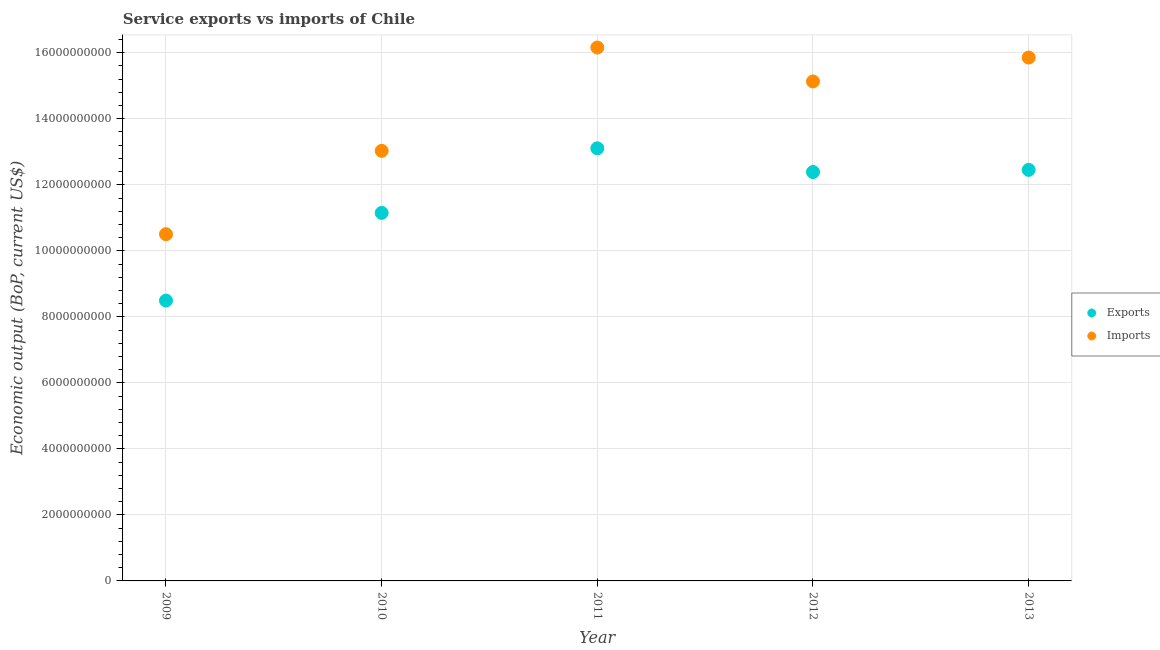Is the number of dotlines equal to the number of legend labels?
Offer a very short reply. Yes. What is the amount of service exports in 2013?
Provide a succinct answer. 1.25e+1. Across all years, what is the maximum amount of service imports?
Keep it short and to the point. 1.62e+1. Across all years, what is the minimum amount of service imports?
Give a very brief answer. 1.05e+1. In which year was the amount of service exports maximum?
Ensure brevity in your answer.  2011. In which year was the amount of service imports minimum?
Ensure brevity in your answer.  2009. What is the total amount of service imports in the graph?
Ensure brevity in your answer.  7.07e+1. What is the difference between the amount of service imports in 2010 and that in 2013?
Provide a succinct answer. -2.83e+09. What is the difference between the amount of service exports in 2011 and the amount of service imports in 2010?
Give a very brief answer. 7.67e+07. What is the average amount of service exports per year?
Offer a terse response. 1.15e+1. In the year 2013, what is the difference between the amount of service imports and amount of service exports?
Your answer should be very brief. 3.40e+09. In how many years, is the amount of service exports greater than 8800000000 US$?
Offer a terse response. 4. What is the ratio of the amount of service exports in 2011 to that in 2013?
Give a very brief answer. 1.05. Is the amount of service exports in 2010 less than that in 2012?
Provide a succinct answer. Yes. Is the difference between the amount of service exports in 2009 and 2011 greater than the difference between the amount of service imports in 2009 and 2011?
Your response must be concise. Yes. What is the difference between the highest and the second highest amount of service exports?
Provide a succinct answer. 6.53e+08. What is the difference between the highest and the lowest amount of service exports?
Your answer should be very brief. 4.61e+09. In how many years, is the amount of service exports greater than the average amount of service exports taken over all years?
Keep it short and to the point. 3. Is the sum of the amount of service exports in 2010 and 2011 greater than the maximum amount of service imports across all years?
Give a very brief answer. Yes. How many dotlines are there?
Provide a succinct answer. 2. How many years are there in the graph?
Your answer should be very brief. 5. How are the legend labels stacked?
Offer a terse response. Vertical. What is the title of the graph?
Your answer should be very brief. Service exports vs imports of Chile. Does "From World Bank" appear as one of the legend labels in the graph?
Make the answer very short. No. What is the label or title of the Y-axis?
Make the answer very short. Economic output (BoP, current US$). What is the Economic output (BoP, current US$) in Exports in 2009?
Your answer should be compact. 8.49e+09. What is the Economic output (BoP, current US$) in Imports in 2009?
Provide a succinct answer. 1.05e+1. What is the Economic output (BoP, current US$) in Exports in 2010?
Give a very brief answer. 1.11e+1. What is the Economic output (BoP, current US$) of Imports in 2010?
Your answer should be very brief. 1.30e+1. What is the Economic output (BoP, current US$) of Exports in 2011?
Your response must be concise. 1.31e+1. What is the Economic output (BoP, current US$) of Imports in 2011?
Ensure brevity in your answer.  1.62e+1. What is the Economic output (BoP, current US$) in Exports in 2012?
Your answer should be compact. 1.24e+1. What is the Economic output (BoP, current US$) of Imports in 2012?
Provide a short and direct response. 1.51e+1. What is the Economic output (BoP, current US$) of Exports in 2013?
Make the answer very short. 1.25e+1. What is the Economic output (BoP, current US$) of Imports in 2013?
Your response must be concise. 1.59e+1. Across all years, what is the maximum Economic output (BoP, current US$) of Exports?
Provide a short and direct response. 1.31e+1. Across all years, what is the maximum Economic output (BoP, current US$) of Imports?
Your answer should be compact. 1.62e+1. Across all years, what is the minimum Economic output (BoP, current US$) in Exports?
Your answer should be very brief. 8.49e+09. Across all years, what is the minimum Economic output (BoP, current US$) of Imports?
Provide a short and direct response. 1.05e+1. What is the total Economic output (BoP, current US$) in Exports in the graph?
Offer a terse response. 5.76e+1. What is the total Economic output (BoP, current US$) of Imports in the graph?
Offer a terse response. 7.07e+1. What is the difference between the Economic output (BoP, current US$) in Exports in 2009 and that in 2010?
Offer a very short reply. -2.66e+09. What is the difference between the Economic output (BoP, current US$) in Imports in 2009 and that in 2010?
Your response must be concise. -2.53e+09. What is the difference between the Economic output (BoP, current US$) of Exports in 2009 and that in 2011?
Your response must be concise. -4.61e+09. What is the difference between the Economic output (BoP, current US$) in Imports in 2009 and that in 2011?
Provide a succinct answer. -5.66e+09. What is the difference between the Economic output (BoP, current US$) of Exports in 2009 and that in 2012?
Keep it short and to the point. -3.89e+09. What is the difference between the Economic output (BoP, current US$) in Imports in 2009 and that in 2012?
Your response must be concise. -4.63e+09. What is the difference between the Economic output (BoP, current US$) of Exports in 2009 and that in 2013?
Ensure brevity in your answer.  -3.96e+09. What is the difference between the Economic output (BoP, current US$) of Imports in 2009 and that in 2013?
Your answer should be compact. -5.35e+09. What is the difference between the Economic output (BoP, current US$) of Exports in 2010 and that in 2011?
Your answer should be very brief. -1.96e+09. What is the difference between the Economic output (BoP, current US$) of Imports in 2010 and that in 2011?
Ensure brevity in your answer.  -3.13e+09. What is the difference between the Economic output (BoP, current US$) of Exports in 2010 and that in 2012?
Provide a short and direct response. -1.24e+09. What is the difference between the Economic output (BoP, current US$) in Imports in 2010 and that in 2012?
Your answer should be compact. -2.10e+09. What is the difference between the Economic output (BoP, current US$) in Exports in 2010 and that in 2013?
Make the answer very short. -1.30e+09. What is the difference between the Economic output (BoP, current US$) of Imports in 2010 and that in 2013?
Offer a terse response. -2.83e+09. What is the difference between the Economic output (BoP, current US$) of Exports in 2011 and that in 2012?
Offer a very short reply. 7.18e+08. What is the difference between the Economic output (BoP, current US$) in Imports in 2011 and that in 2012?
Your answer should be very brief. 1.03e+09. What is the difference between the Economic output (BoP, current US$) in Exports in 2011 and that in 2013?
Keep it short and to the point. 6.53e+08. What is the difference between the Economic output (BoP, current US$) of Imports in 2011 and that in 2013?
Offer a very short reply. 3.04e+08. What is the difference between the Economic output (BoP, current US$) of Exports in 2012 and that in 2013?
Make the answer very short. -6.53e+07. What is the difference between the Economic output (BoP, current US$) of Imports in 2012 and that in 2013?
Give a very brief answer. -7.24e+08. What is the difference between the Economic output (BoP, current US$) of Exports in 2009 and the Economic output (BoP, current US$) of Imports in 2010?
Give a very brief answer. -4.54e+09. What is the difference between the Economic output (BoP, current US$) of Exports in 2009 and the Economic output (BoP, current US$) of Imports in 2011?
Your answer should be very brief. -7.67e+09. What is the difference between the Economic output (BoP, current US$) in Exports in 2009 and the Economic output (BoP, current US$) in Imports in 2012?
Offer a very short reply. -6.64e+09. What is the difference between the Economic output (BoP, current US$) of Exports in 2009 and the Economic output (BoP, current US$) of Imports in 2013?
Give a very brief answer. -7.36e+09. What is the difference between the Economic output (BoP, current US$) in Exports in 2010 and the Economic output (BoP, current US$) in Imports in 2011?
Make the answer very short. -5.01e+09. What is the difference between the Economic output (BoP, current US$) in Exports in 2010 and the Economic output (BoP, current US$) in Imports in 2012?
Ensure brevity in your answer.  -3.98e+09. What is the difference between the Economic output (BoP, current US$) of Exports in 2010 and the Economic output (BoP, current US$) of Imports in 2013?
Ensure brevity in your answer.  -4.71e+09. What is the difference between the Economic output (BoP, current US$) of Exports in 2011 and the Economic output (BoP, current US$) of Imports in 2012?
Ensure brevity in your answer.  -2.03e+09. What is the difference between the Economic output (BoP, current US$) in Exports in 2011 and the Economic output (BoP, current US$) in Imports in 2013?
Offer a very short reply. -2.75e+09. What is the difference between the Economic output (BoP, current US$) in Exports in 2012 and the Economic output (BoP, current US$) in Imports in 2013?
Keep it short and to the point. -3.47e+09. What is the average Economic output (BoP, current US$) of Exports per year?
Provide a succinct answer. 1.15e+1. What is the average Economic output (BoP, current US$) of Imports per year?
Keep it short and to the point. 1.41e+1. In the year 2009, what is the difference between the Economic output (BoP, current US$) of Exports and Economic output (BoP, current US$) of Imports?
Provide a succinct answer. -2.01e+09. In the year 2010, what is the difference between the Economic output (BoP, current US$) in Exports and Economic output (BoP, current US$) in Imports?
Give a very brief answer. -1.88e+09. In the year 2011, what is the difference between the Economic output (BoP, current US$) in Exports and Economic output (BoP, current US$) in Imports?
Give a very brief answer. -3.05e+09. In the year 2012, what is the difference between the Economic output (BoP, current US$) in Exports and Economic output (BoP, current US$) in Imports?
Your response must be concise. -2.74e+09. In the year 2013, what is the difference between the Economic output (BoP, current US$) in Exports and Economic output (BoP, current US$) in Imports?
Provide a succinct answer. -3.40e+09. What is the ratio of the Economic output (BoP, current US$) of Exports in 2009 to that in 2010?
Offer a terse response. 0.76. What is the ratio of the Economic output (BoP, current US$) of Imports in 2009 to that in 2010?
Your answer should be very brief. 0.81. What is the ratio of the Economic output (BoP, current US$) in Exports in 2009 to that in 2011?
Provide a succinct answer. 0.65. What is the ratio of the Economic output (BoP, current US$) in Imports in 2009 to that in 2011?
Give a very brief answer. 0.65. What is the ratio of the Economic output (BoP, current US$) in Exports in 2009 to that in 2012?
Offer a very short reply. 0.69. What is the ratio of the Economic output (BoP, current US$) in Imports in 2009 to that in 2012?
Provide a succinct answer. 0.69. What is the ratio of the Economic output (BoP, current US$) in Exports in 2009 to that in 2013?
Offer a very short reply. 0.68. What is the ratio of the Economic output (BoP, current US$) of Imports in 2009 to that in 2013?
Provide a short and direct response. 0.66. What is the ratio of the Economic output (BoP, current US$) in Exports in 2010 to that in 2011?
Provide a succinct answer. 0.85. What is the ratio of the Economic output (BoP, current US$) in Imports in 2010 to that in 2011?
Offer a very short reply. 0.81. What is the ratio of the Economic output (BoP, current US$) in Exports in 2010 to that in 2012?
Provide a succinct answer. 0.9. What is the ratio of the Economic output (BoP, current US$) in Imports in 2010 to that in 2012?
Provide a short and direct response. 0.86. What is the ratio of the Economic output (BoP, current US$) in Exports in 2010 to that in 2013?
Offer a terse response. 0.9. What is the ratio of the Economic output (BoP, current US$) of Imports in 2010 to that in 2013?
Provide a succinct answer. 0.82. What is the ratio of the Economic output (BoP, current US$) in Exports in 2011 to that in 2012?
Your answer should be compact. 1.06. What is the ratio of the Economic output (BoP, current US$) in Imports in 2011 to that in 2012?
Ensure brevity in your answer.  1.07. What is the ratio of the Economic output (BoP, current US$) of Exports in 2011 to that in 2013?
Make the answer very short. 1.05. What is the ratio of the Economic output (BoP, current US$) in Imports in 2011 to that in 2013?
Your answer should be very brief. 1.02. What is the ratio of the Economic output (BoP, current US$) of Imports in 2012 to that in 2013?
Ensure brevity in your answer.  0.95. What is the difference between the highest and the second highest Economic output (BoP, current US$) in Exports?
Your answer should be very brief. 6.53e+08. What is the difference between the highest and the second highest Economic output (BoP, current US$) in Imports?
Your response must be concise. 3.04e+08. What is the difference between the highest and the lowest Economic output (BoP, current US$) in Exports?
Make the answer very short. 4.61e+09. What is the difference between the highest and the lowest Economic output (BoP, current US$) of Imports?
Provide a short and direct response. 5.66e+09. 